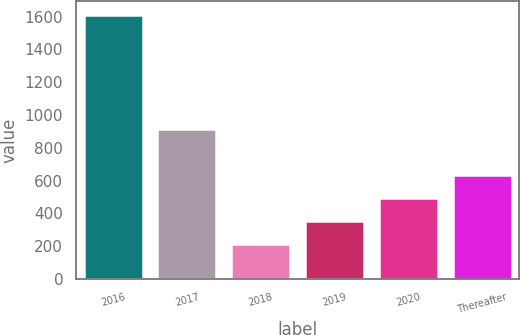Convert chart. <chart><loc_0><loc_0><loc_500><loc_500><bar_chart><fcel>2016<fcel>2017<fcel>2018<fcel>2019<fcel>2020<fcel>Thereafter<nl><fcel>1613<fcel>913<fcel>213<fcel>353<fcel>493<fcel>633<nl></chart> 